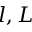<formula> <loc_0><loc_0><loc_500><loc_500>l , L</formula> 